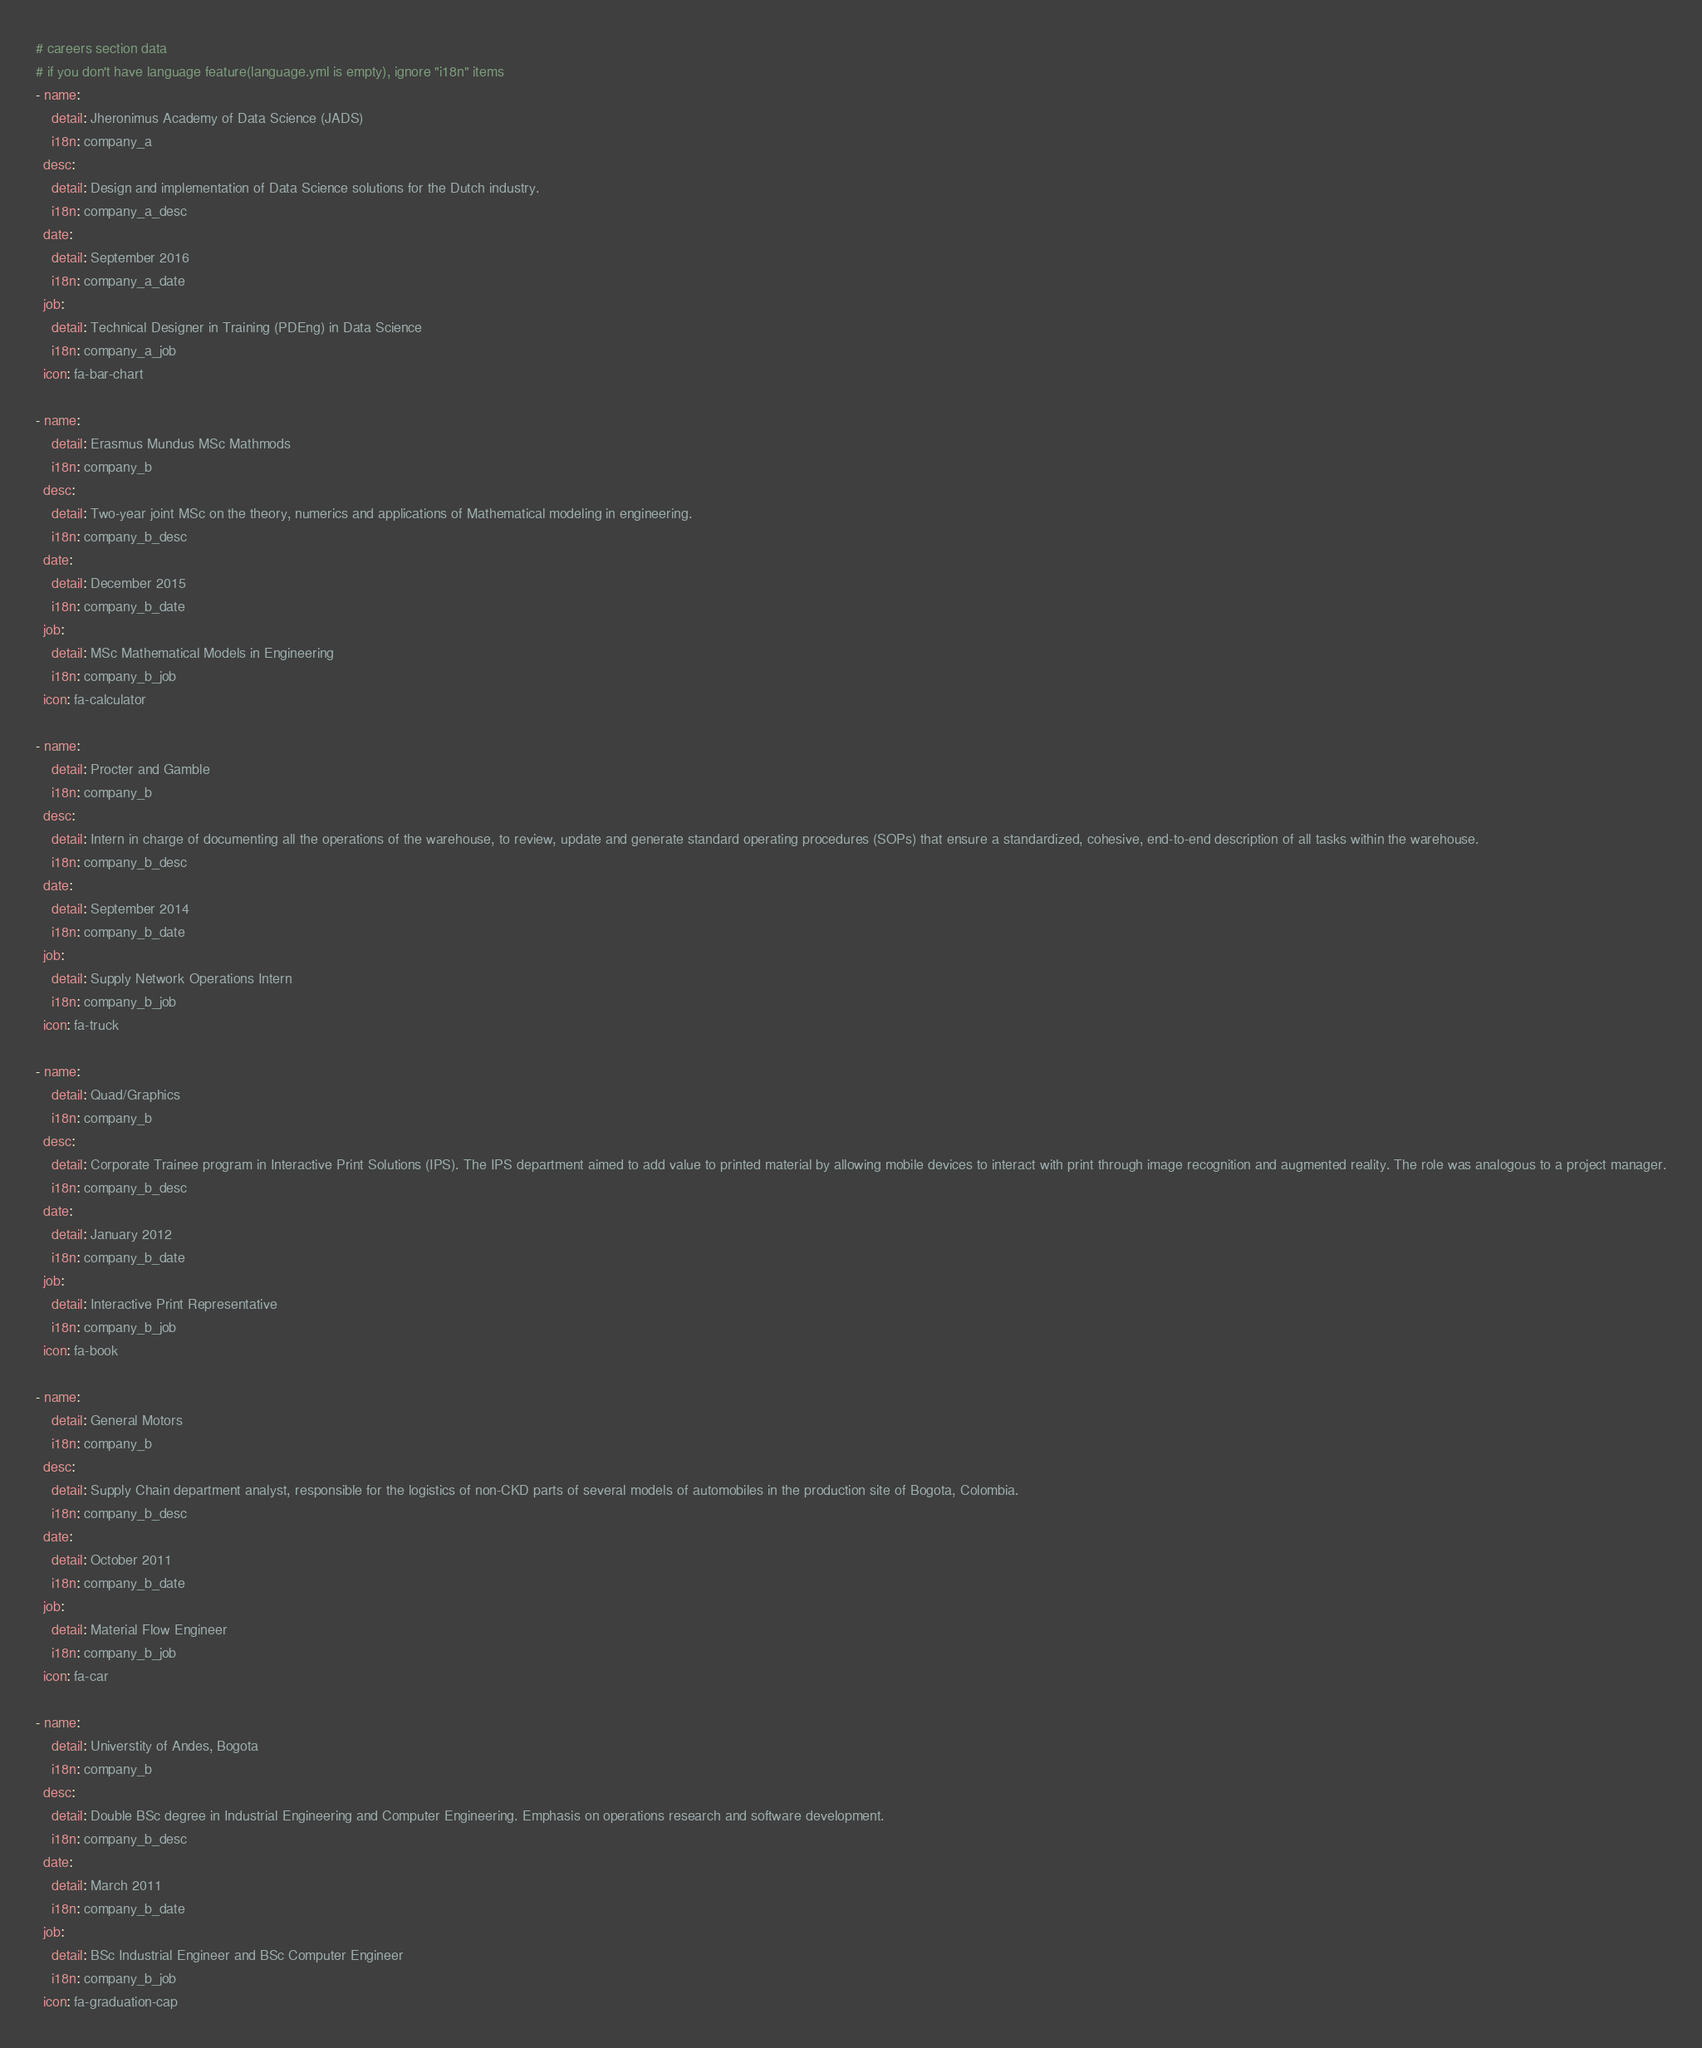Convert code to text. <code><loc_0><loc_0><loc_500><loc_500><_YAML_># careers section data
# if you don't have language feature(language.yml is empty), ignore "i18n" items
- name:
    detail: Jheronimus Academy of Data Science (JADS)
    i18n: company_a
  desc:
    detail: Design and implementation of Data Science solutions for the Dutch industry.
    i18n: company_a_desc
  date:
    detail: September 2016
    i18n: company_a_date
  job:
    detail: Technical Designer in Training (PDEng) in Data Science
    i18n: company_a_job
  icon: fa-bar-chart

- name:
    detail: Erasmus Mundus MSc Mathmods
    i18n: company_b
  desc:
    detail: Two-year joint MSc on the theory, numerics and applications of Mathematical modeling in engineering.
    i18n: company_b_desc
  date:
    detail: December 2015
    i18n: company_b_date
  job:
    detail: MSc Mathematical Models in Engineering
    i18n: company_b_job
  icon: fa-calculator

- name:
    detail: Procter and Gamble
    i18n: company_b
  desc:
    detail: Intern in charge of documenting all the operations of the warehouse, to review, update and generate standard operating procedures (SOPs) that ensure a standardized, cohesive, end-to-end description of all tasks within the warehouse.
    i18n: company_b_desc
  date:
    detail: September 2014
    i18n: company_b_date
  job:
    detail: Supply Network Operations Intern
    i18n: company_b_job
  icon: fa-truck

- name:
    detail: Quad/Graphics
    i18n: company_b
  desc:
    detail: Corporate Trainee program in Interactive Print Solutions (IPS). The IPS department aimed to add value to printed material by allowing mobile devices to interact with print through image recognition and augmented reality. The role was analogous to a project manager.
    i18n: company_b_desc
  date:
    detail: January 2012
    i18n: company_b_date
  job:
    detail: Interactive Print Representative
    i18n: company_b_job
  icon: fa-book

- name:
    detail: General Motors
    i18n: company_b
  desc:
    detail: Supply Chain department analyst, responsible for the logistics of non-CKD parts of several models of automobiles in the production site of Bogota, Colombia.
    i18n: company_b_desc
  date:
    detail: October 2011
    i18n: company_b_date
  job:
    detail: Material Flow Engineer
    i18n: company_b_job
  icon: fa-car

- name:
    detail: Universtity of Andes, Bogota
    i18n: company_b
  desc:
    detail: Double BSc degree in Industrial Engineering and Computer Engineering. Emphasis on operations research and software development.
    i18n: company_b_desc
  date:
    detail: March 2011
    i18n: company_b_date
  job:
    detail: BSc Industrial Engineer and BSc Computer Engineer
    i18n: company_b_job
  icon: fa-graduation-cap
</code> 